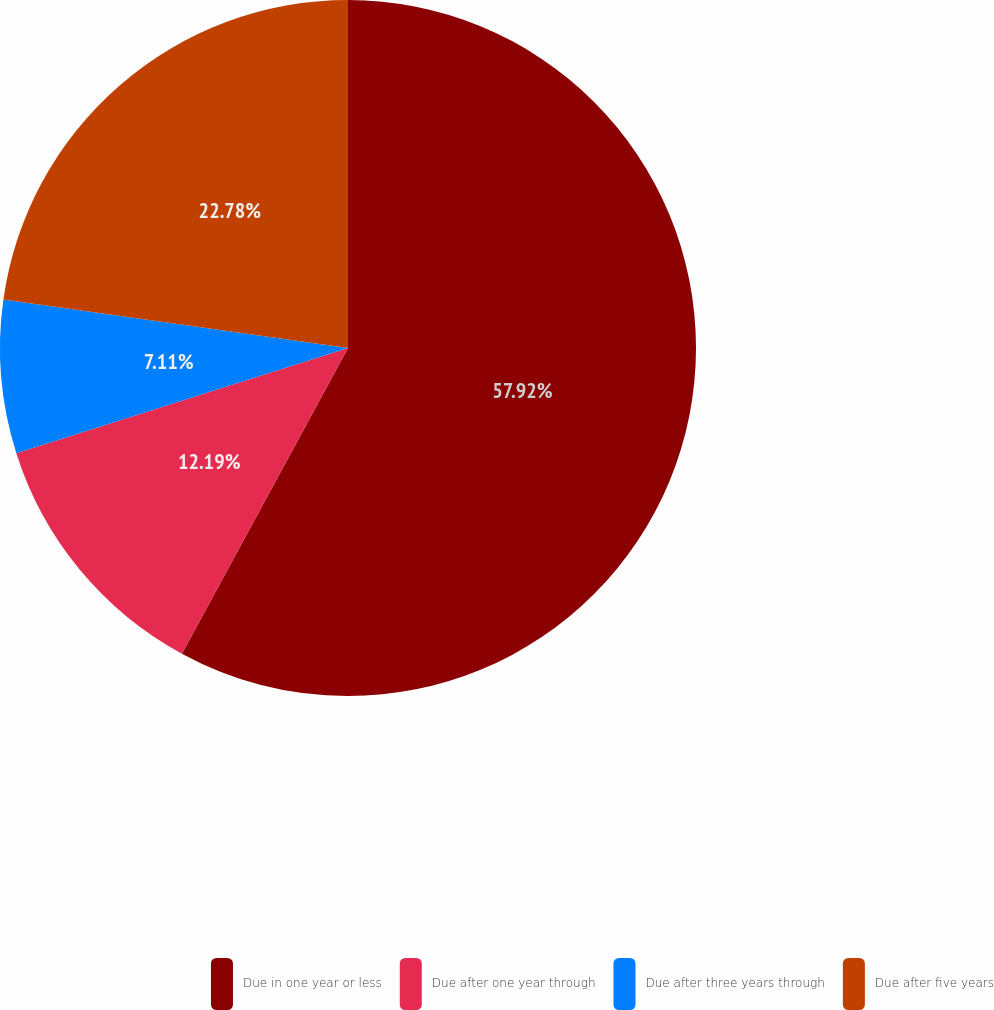Convert chart to OTSL. <chart><loc_0><loc_0><loc_500><loc_500><pie_chart><fcel>Due in one year or less<fcel>Due after one year through<fcel>Due after three years through<fcel>Due after five years<nl><fcel>57.92%<fcel>12.19%<fcel>7.11%<fcel>22.78%<nl></chart> 